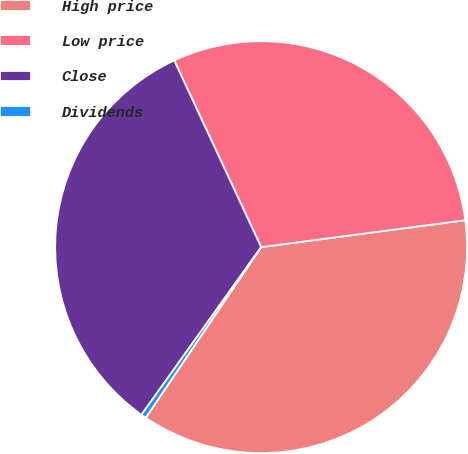Convert chart. <chart><loc_0><loc_0><loc_500><loc_500><pie_chart><fcel>High price<fcel>Low price<fcel>Close<fcel>Dividends<nl><fcel>36.56%<fcel>29.85%<fcel>33.2%<fcel>0.4%<nl></chart> 